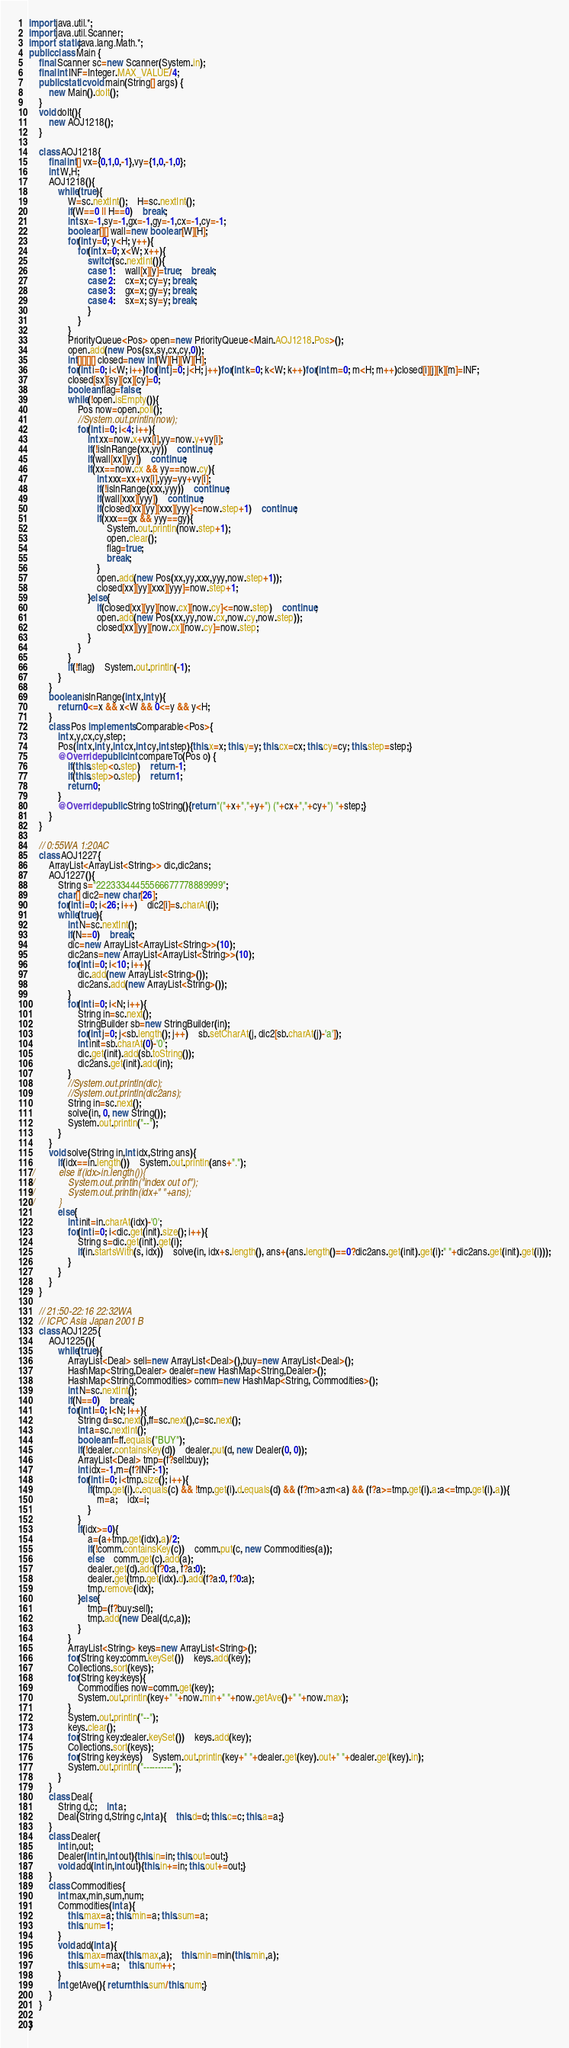Convert code to text. <code><loc_0><loc_0><loc_500><loc_500><_Java_>import java.util.*;
import java.util.Scanner;
import static java.lang.Math.*;
public class Main {
	final Scanner sc=new Scanner(System.in);
	final int INF=Integer.MAX_VALUE/4;
	public static void main(String[] args) {
		new Main().doIt();
	}
	void doIt(){
		new AOJ1218();
	}
	
	class AOJ1218{
		final int[] vx={0,1,0,-1},vy={1,0,-1,0};
		int W,H;
		AOJ1218(){
			while(true){
				W=sc.nextInt();	H=sc.nextInt();
				if(W==0 || H==0)	break;
				int sx=-1,sy=-1,gx=-1,gy=-1,cx=-1,cy=-1;
				boolean[][] wall=new boolean[W][H];
				for(int y=0; y<H; y++){
					for(int x=0; x<W; x++){
						switch(sc.nextInt()){
						case 1:	wall[x][y]=true;	break;
						case 2:	cx=x; cy=y; break;
						case 3:	gx=x; gy=y; break;
						case 4:	sx=x; sy=y; break;
						}
					}
				}
				PriorityQueue<Pos> open=new PriorityQueue<Main.AOJ1218.Pos>();
				open.add(new Pos(sx,sy,cx,cy,0));
				int[][][][] closed=new int[W][H][W][H];
				for(int i=0; i<W; i++)for(int j=0; j<H; j++)for(int k=0; k<W; k++)for(int m=0; m<H; m++)closed[i][j][k][m]=INF;
				closed[sx][sy][cx][cy]=0;
				boolean flag=false;
				while(!open.isEmpty()){
					Pos now=open.poll();
					//System.out.println(now);
					for(int i=0; i<4; i++){
						int xx=now.x+vx[i],yy=now.y+vy[i];
						if(!isInRange(xx,yy))	continue;
						if(wall[xx][yy])	continue;
						if(xx==now.cx && yy==now.cy){
							int xxx=xx+vx[i],yyy=yy+vy[i];
							if(!isInRange(xxx,yyy))	continue;
							if(wall[xxx][yyy])	continue;
							if(closed[xx][yy][xxx][yyy]<=now.step+1)	continue;
							if(xxx==gx && yyy==gy){
								System.out.println(now.step+1);
								open.clear();
								flag=true;
								break;
							}
							open.add(new Pos(xx,yy,xxx,yyy,now.step+1));
							closed[xx][yy][xxx][yyy]=now.step+1;
						}else{
							if(closed[xx][yy][now.cx][now.cy]<=now.step)	continue;
							open.add(new Pos(xx,yy,now.cx,now.cy,now.step));
							closed[xx][yy][now.cx][now.cy]=now.step;
						}
					}
				}
				if(!flag)	System.out.println(-1);
			}
		}
		boolean isInRange(int x,int y){
			return 0<=x && x<W && 0<=y && y<H;
		}
		class Pos implements Comparable<Pos>{
			int x,y,cx,cy,step;
			Pos(int x,int y,int cx,int cy,int step){this.x=x; this.y=y; this.cx=cx; this.cy=cy; this.step=step;}
			@Override public int compareTo(Pos o) {
				if(this.step<o.step)	return -1;
				if(this.step>o.step)	return 1;
				return 0;
			}
			@Override public String toString(){return "("+x+","+y+") ("+cx+","+cy+") "+step;}
		}
	}
	
	// 0:55WA 1:20AC
	class AOJ1227{
		ArrayList<ArrayList<String>> dic,dic2ans;
		AOJ1227(){
			String s="22233344455566677778889999";
			char[] dic2=new char[26];
			for(int i=0; i<26; i++)	dic2[i]=s.charAt(i);
			while(true){
				int N=sc.nextInt();
				if(N==0)	break;
				dic=new ArrayList<ArrayList<String>>(10);
				dic2ans=new ArrayList<ArrayList<String>>(10);
				for(int i=0; i<10; i++){
					dic.add(new ArrayList<String>());
					dic2ans.add(new ArrayList<String>());
				}
				for(int i=0; i<N; i++){
					String in=sc.next();
					StringBuilder sb=new StringBuilder(in);
					for(int j=0; j<sb.length(); j++)	sb.setCharAt(j, dic2[sb.charAt(j)-'a']);
					int init=sb.charAt(0)-'0';
					dic.get(init).add(sb.toString());
					dic2ans.get(init).add(in);
				}
				//System.out.println(dic);
				//System.out.println(dic2ans);
				String in=sc.next();
				solve(in, 0, new String());
				System.out.println("--");
			}
		}
		void solve(String in,int idx,String ans){
			if(idx==in.length())	System.out.println(ans+".");
//			else if(idx>in.length()){
//				System.out.println("index out of");
//				System.out.println(idx+" "+ans);
//			}
			else{
				int init=in.charAt(idx)-'0';
				for(int i=0; i<dic.get(init).size(); i++){
					String s=dic.get(init).get(i);
					if(in.startsWith(s, idx))	solve(in, idx+s.length(), ans+(ans.length()==0?dic2ans.get(init).get(i):" "+dic2ans.get(init).get(i)));
				}
			}
		}
	}
	
	// 21:50-22:16 22:32WA
	// ICPC Asia Japan 2001 B
	class AOJ1225{
		AOJ1225(){
			while(true){
				ArrayList<Deal> sell=new ArrayList<Deal>(),buy=new ArrayList<Deal>();
				HashMap<String,Dealer> dealer=new HashMap<String,Dealer>();
				HashMap<String,Commodities> comm=new HashMap<String, Commodities>();
				int N=sc.nextInt();
				if(N==0)	break;
				for(int I=0; I<N; I++){
					String d=sc.next(),ff=sc.next(),c=sc.next();
					int a=sc.nextInt();
					boolean f=ff.equals("BUY");
					if(!dealer.containsKey(d))	dealer.put(d, new Dealer(0, 0));
					ArrayList<Deal> tmp=(f?sell:buy);
					int idx=-1,m=(f?INF:-1);
					for(int i=0; i<tmp.size(); i++){
						if(tmp.get(i).c.equals(c) && !tmp.get(i).d.equals(d) && (f?m>a:m<a) && (f?a>=tmp.get(i).a:a<=tmp.get(i).a)){
							m=a;	idx=i;
						}
					}
					if(idx>=0){
						a=(a+tmp.get(idx).a)/2;
						if(!comm.containsKey(c))	comm.put(c, new Commodities(a));
						else	comm.get(c).add(a);
						dealer.get(d).add(f?0:a, f?a:0);
						dealer.get(tmp.get(idx).d).add(f?a:0, f?0:a);
						tmp.remove(idx);
					}else{
						tmp=(f?buy:sell);
						tmp.add(new Deal(d,c,a));
					}
				}
				ArrayList<String> keys=new ArrayList<String>();
				for(String key:comm.keySet())	keys.add(key);
				Collections.sort(keys);
				for(String key:keys){
					Commodities now=comm.get(key);
					System.out.println(key+" "+now.min+" "+now.getAve()+" "+now.max);
				}
				System.out.println("--");
				keys.clear();
				for(String key:dealer.keySet())	keys.add(key);
				Collections.sort(keys);
				for(String key:keys)	System.out.println(key+" "+dealer.get(key).out+" "+dealer.get(key).in);
				System.out.println("----------");
			}
		}
		class Deal{
			String d,c;	int a;
			Deal(String d,String c,int a){	this.d=d; this.c=c; this.a=a;}
		}
		class Dealer{
			int in,out;
			Dealer(int in,int out){this.in=in; this.out=out;}
			void add(int in,int out){this.in+=in; this.out+=out;}
		}
		class Commodities{
			int max,min,sum,num;
			Commodities(int a){
				this.max=a; this.min=a; this.sum=a;
				this.num=1;
			}
			void add(int a){
				this.max=max(this.max,a);	this.min=min(this.min,a);
				this.sum+=a;	this.num++;
			}
			int getAve(){ return this.sum/this.num;}
		}
	}

}</code> 